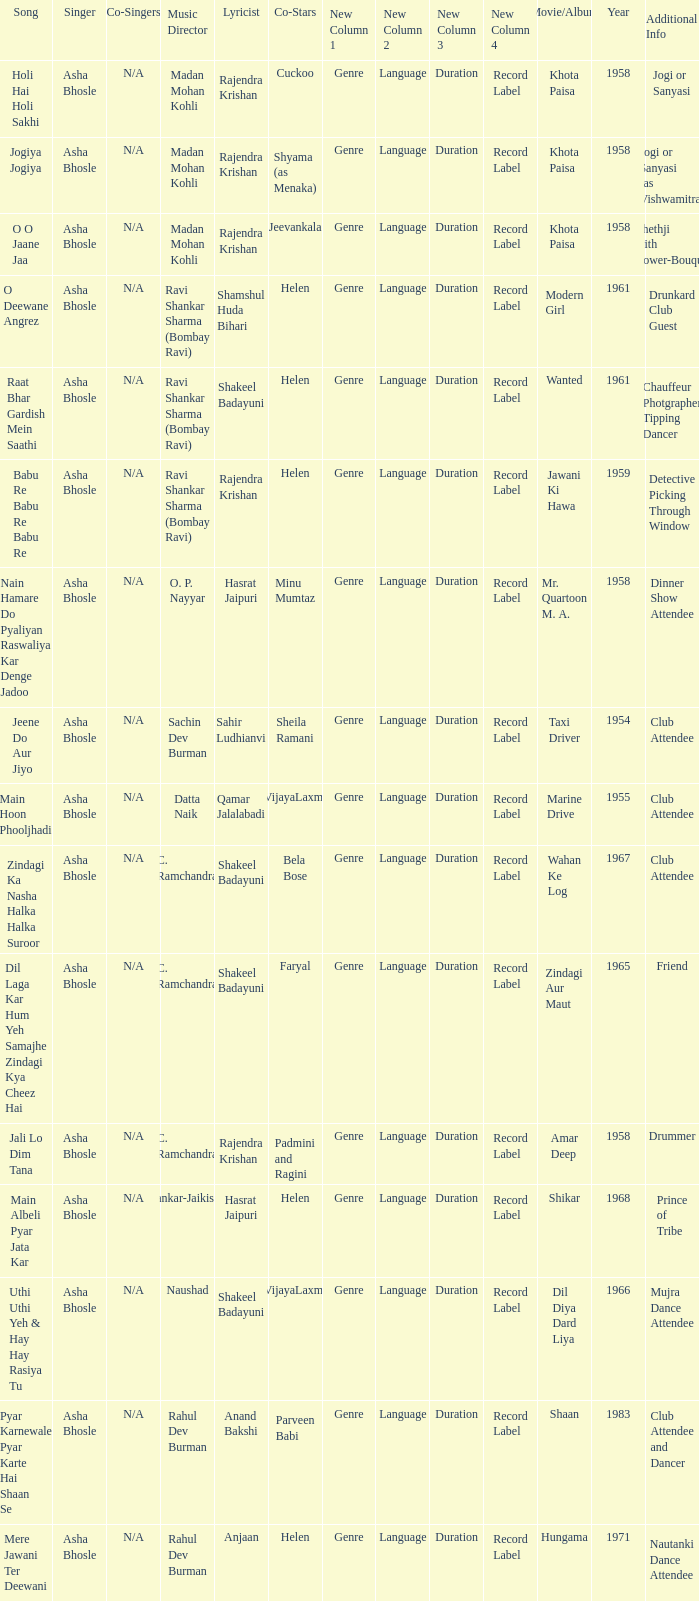What year did Naushad Direct the Music? 1966.0. 